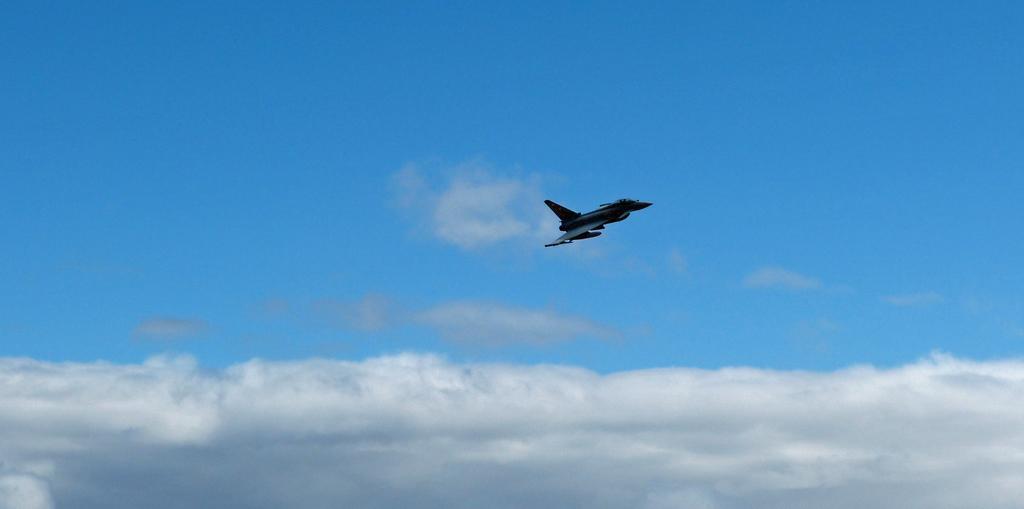Could you give a brief overview of what you see in this image? In this picture there is an aircraft flying. At the top there is sky. At the bottom there are clouds. 